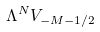<formula> <loc_0><loc_0><loc_500><loc_500>\Lambda ^ { N } V _ { - M - 1 / 2 }</formula> 